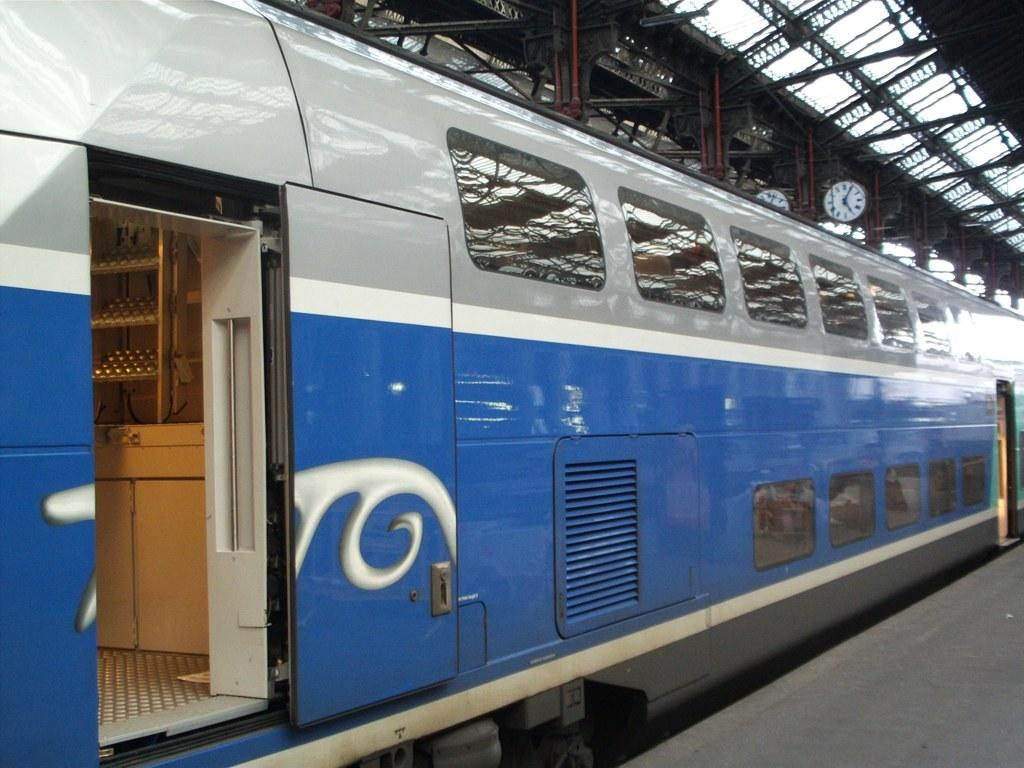Where was the image taken? The image was taken at a railway station. What can be seen in the foreground of the image? There is a train and a platform in the foreground of the image. What architectural features are visible at the top of the image? There are iron frames and the ceiling visible at the top of the image. Is there any time-related object in the image? Yes, there is a clock in the image. What type of coil is being used to heat the water in the image? There is no coil or water present in the image; it is taken at a railway station with a train, platform, iron frames, ceiling, and a clock. 